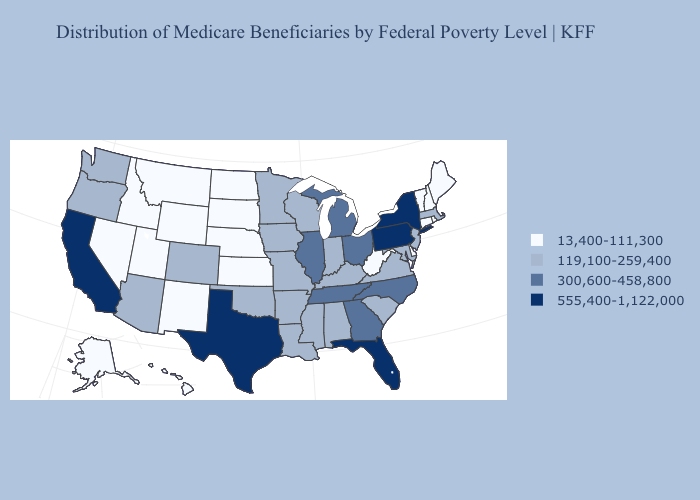What is the value of Ohio?
Give a very brief answer. 300,600-458,800. What is the highest value in the USA?
Be succinct. 555,400-1,122,000. Among the states that border Washington , does Idaho have the highest value?
Give a very brief answer. No. Does Virginia have a lower value than Georgia?
Keep it brief. Yes. What is the value of Alabama?
Concise answer only. 119,100-259,400. Does North Carolina have a higher value than Missouri?
Short answer required. Yes. Does the map have missing data?
Be succinct. No. What is the lowest value in states that border Arkansas?
Be succinct. 119,100-259,400. Name the states that have a value in the range 119,100-259,400?
Keep it brief. Alabama, Arizona, Arkansas, Colorado, Indiana, Iowa, Kentucky, Louisiana, Maryland, Massachusetts, Minnesota, Mississippi, Missouri, New Jersey, Oklahoma, Oregon, South Carolina, Virginia, Washington, Wisconsin. What is the value of West Virginia?
Short answer required. 13,400-111,300. Name the states that have a value in the range 13,400-111,300?
Quick response, please. Alaska, Connecticut, Delaware, Hawaii, Idaho, Kansas, Maine, Montana, Nebraska, Nevada, New Hampshire, New Mexico, North Dakota, Rhode Island, South Dakota, Utah, Vermont, West Virginia, Wyoming. Which states have the lowest value in the USA?
Be succinct. Alaska, Connecticut, Delaware, Hawaii, Idaho, Kansas, Maine, Montana, Nebraska, Nevada, New Hampshire, New Mexico, North Dakota, Rhode Island, South Dakota, Utah, Vermont, West Virginia, Wyoming. Name the states that have a value in the range 119,100-259,400?
Keep it brief. Alabama, Arizona, Arkansas, Colorado, Indiana, Iowa, Kentucky, Louisiana, Maryland, Massachusetts, Minnesota, Mississippi, Missouri, New Jersey, Oklahoma, Oregon, South Carolina, Virginia, Washington, Wisconsin. What is the value of Arizona?
Quick response, please. 119,100-259,400. Does Wyoming have the same value as Arkansas?
Quick response, please. No. 